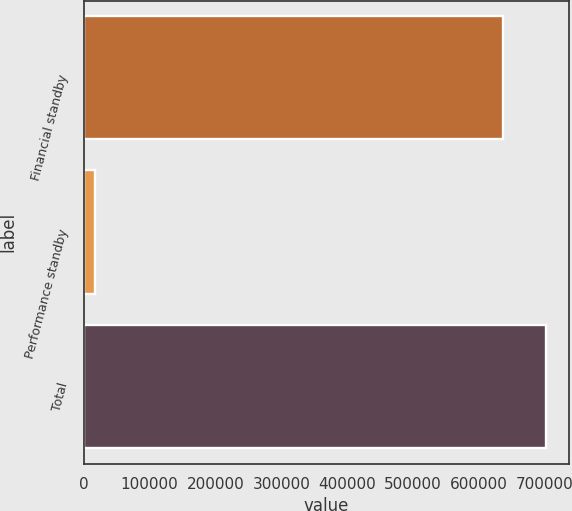Convert chart to OTSL. <chart><loc_0><loc_0><loc_500><loc_500><bar_chart><fcel>Financial standby<fcel>Performance standby<fcel>Total<nl><fcel>637321<fcel>16970<fcel>702368<nl></chart> 